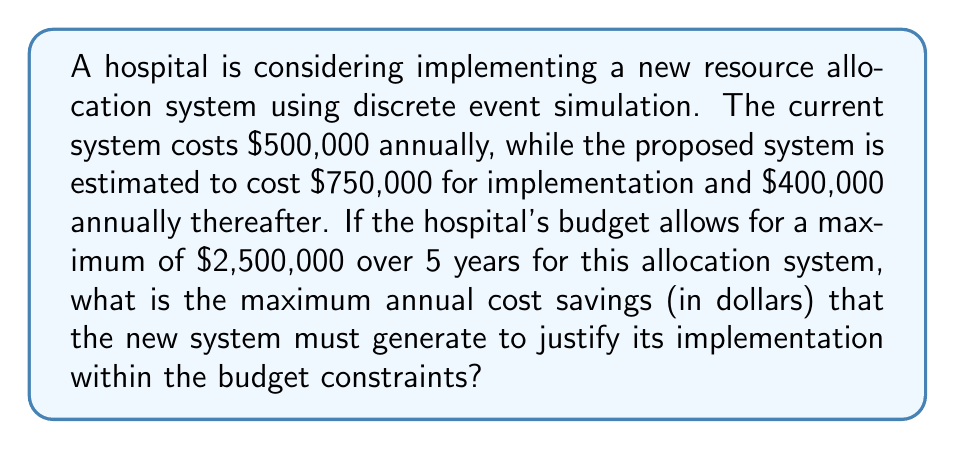Teach me how to tackle this problem. Let's approach this step-by-step:

1) First, let's calculate the total cost of the current system over 5 years:
   $$500,000 \times 5 = 2,500,000$$

2) Now, let's calculate the total cost of the new system over 5 years:
   Implementation cost: $750,000
   Annual cost: $400,000 × 5 = $2,000,000
   Total: $$750,000 + 2,000,000 = 2,750,000$$

3) The difference between the new system and the current system over 5 years is:
   $$2,750,000 - 2,500,000 = 250,000$$

4) This $250,000 is the amount that needs to be saved over 5 years to justify the new system within the budget constraints.

5) To find the annual savings needed, we divide this amount by 5:
   $$\frac{250,000}{5} = 50,000$$

Therefore, the new system needs to generate at least $50,000 in annual cost savings to justify its implementation within the given budget constraints.
Answer: $50,000 